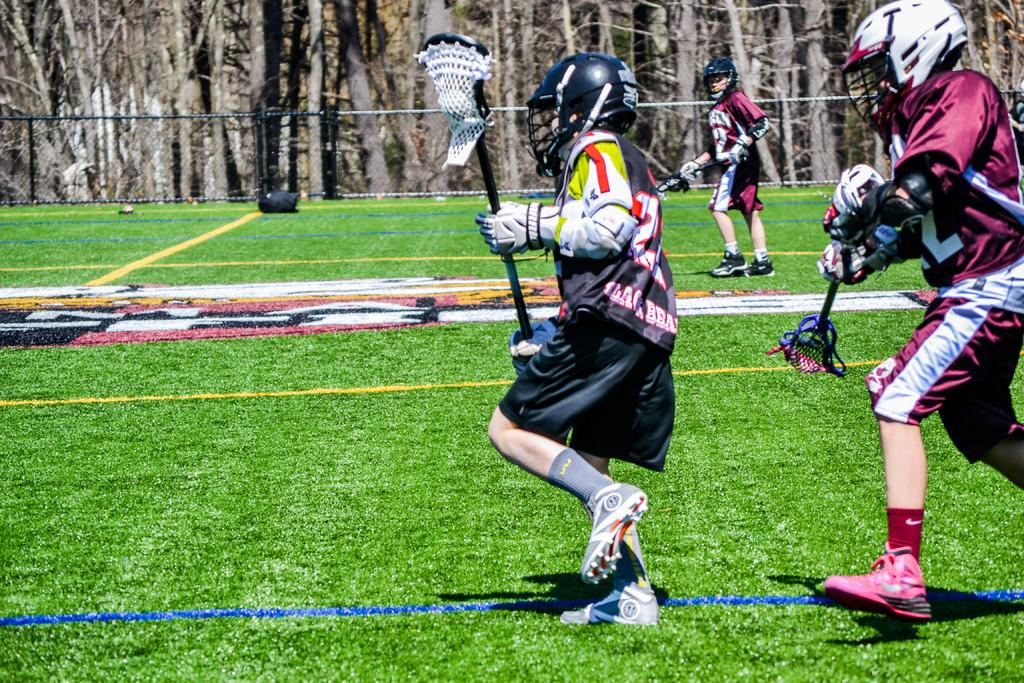How many people are in the image? There are three persons in the image. What are the persons holding in their hands? The persons are standing and holding bats. What can be seen in the background of the image? There are trees in the background of the image. Is there any architectural feature visible in the image? Yes, there is a fence in the image. What type of soda is being consumed by the person on the left in the image? There is no soda present in the image; the persons are holding bats and standing near a fence. Can you describe the leaf that is falling from the tree in the image? There is no leaf falling from the tree in the image; only trees are visible in the background. 